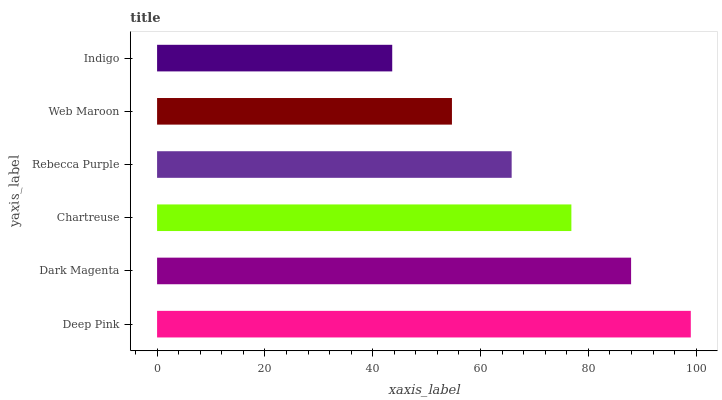Is Indigo the minimum?
Answer yes or no. Yes. Is Deep Pink the maximum?
Answer yes or no. Yes. Is Dark Magenta the minimum?
Answer yes or no. No. Is Dark Magenta the maximum?
Answer yes or no. No. Is Deep Pink greater than Dark Magenta?
Answer yes or no. Yes. Is Dark Magenta less than Deep Pink?
Answer yes or no. Yes. Is Dark Magenta greater than Deep Pink?
Answer yes or no. No. Is Deep Pink less than Dark Magenta?
Answer yes or no. No. Is Chartreuse the high median?
Answer yes or no. Yes. Is Rebecca Purple the low median?
Answer yes or no. Yes. Is Deep Pink the high median?
Answer yes or no. No. Is Chartreuse the low median?
Answer yes or no. No. 